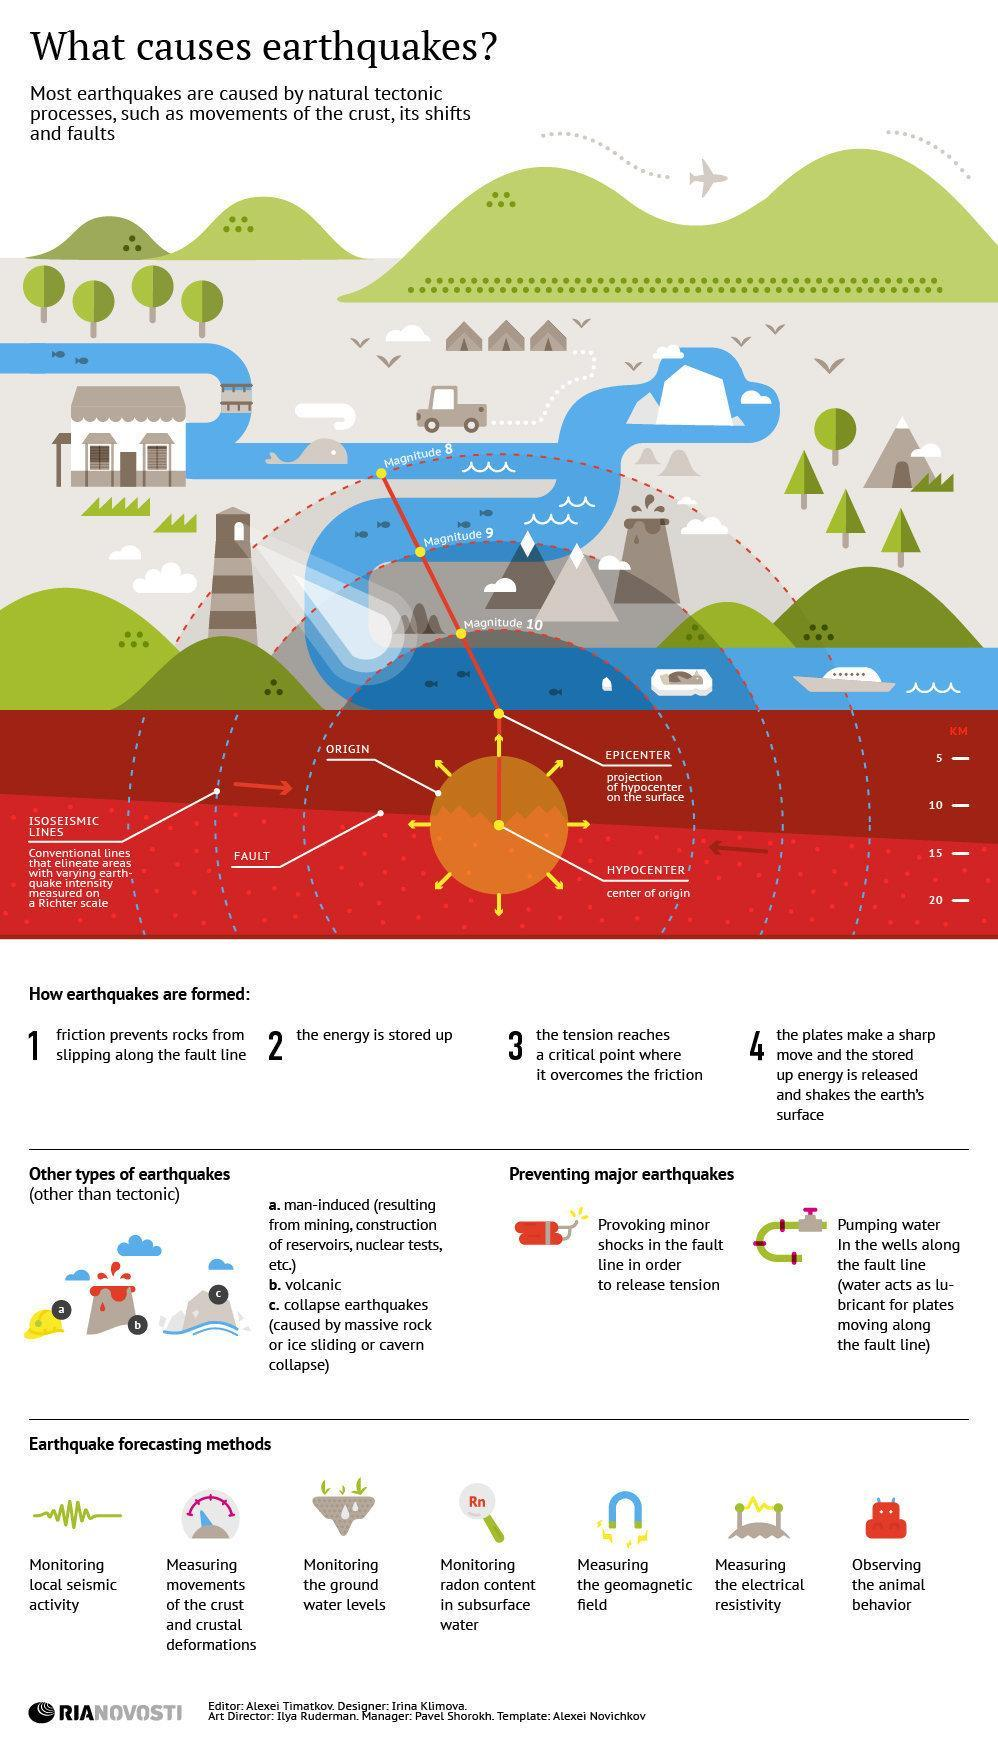what is the centre of origin
Answer the question with a short phrase. hypocenter how is the intensity of earthquake measured richter scale 